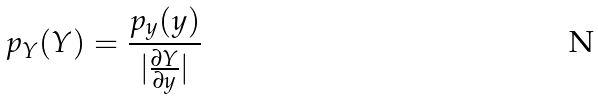<formula> <loc_0><loc_0><loc_500><loc_500>p _ { Y } ( Y ) = \frac { p _ { y } ( y ) } { | \frac { \partial Y } { \partial y } | }</formula> 